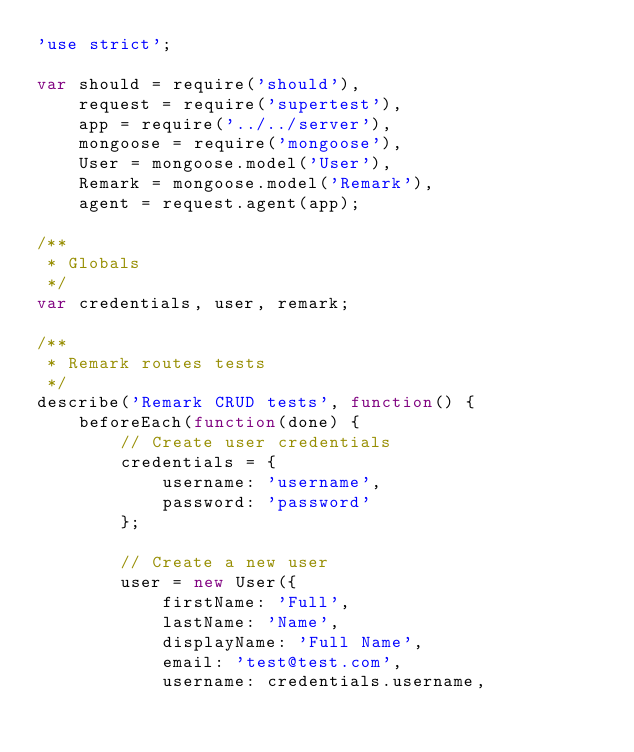<code> <loc_0><loc_0><loc_500><loc_500><_JavaScript_>'use strict';

var should = require('should'),
	request = require('supertest'),
	app = require('../../server'),
	mongoose = require('mongoose'),
	User = mongoose.model('User'),
	Remark = mongoose.model('Remark'),
	agent = request.agent(app);

/**
 * Globals
 */
var credentials, user, remark;

/**
 * Remark routes tests
 */
describe('Remark CRUD tests', function() {
	beforeEach(function(done) {
		// Create user credentials
		credentials = {
			username: 'username',
			password: 'password'
		};

		// Create a new user
		user = new User({
			firstName: 'Full',
			lastName: 'Name',
			displayName: 'Full Name',
			email: 'test@test.com',
			username: credentials.username,</code> 